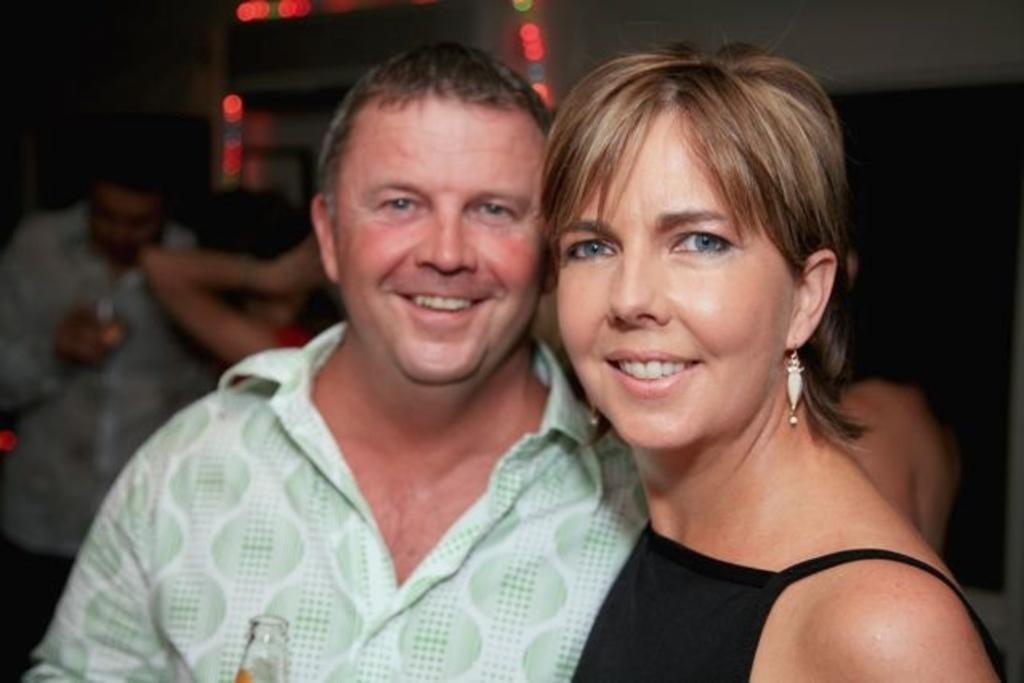How would you summarize this image in a sentence or two? In this image we can see man and woman. Woman is wearing black color and man is wearing green color shirt and holding bottle. Background of the image people are present. 